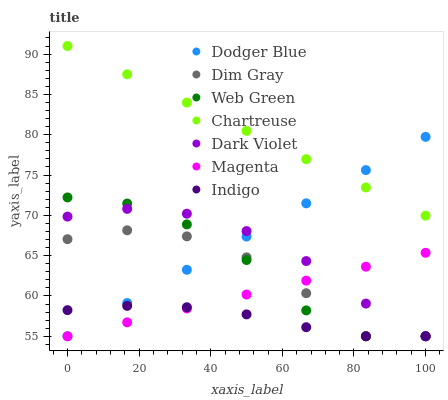Does Indigo have the minimum area under the curve?
Answer yes or no. Yes. Does Chartreuse have the maximum area under the curve?
Answer yes or no. Yes. Does Dark Violet have the minimum area under the curve?
Answer yes or no. No. Does Dark Violet have the maximum area under the curve?
Answer yes or no. No. Is Dodger Blue the smoothest?
Answer yes or no. Yes. Is Dim Gray the roughest?
Answer yes or no. Yes. Is Indigo the smoothest?
Answer yes or no. No. Is Indigo the roughest?
Answer yes or no. No. Does Dim Gray have the lowest value?
Answer yes or no. Yes. Does Chartreuse have the lowest value?
Answer yes or no. No. Does Chartreuse have the highest value?
Answer yes or no. Yes. Does Dark Violet have the highest value?
Answer yes or no. No. Is Dim Gray less than Chartreuse?
Answer yes or no. Yes. Is Chartreuse greater than Dim Gray?
Answer yes or no. Yes. Does Dim Gray intersect Web Green?
Answer yes or no. Yes. Is Dim Gray less than Web Green?
Answer yes or no. No. Is Dim Gray greater than Web Green?
Answer yes or no. No. Does Dim Gray intersect Chartreuse?
Answer yes or no. No. 